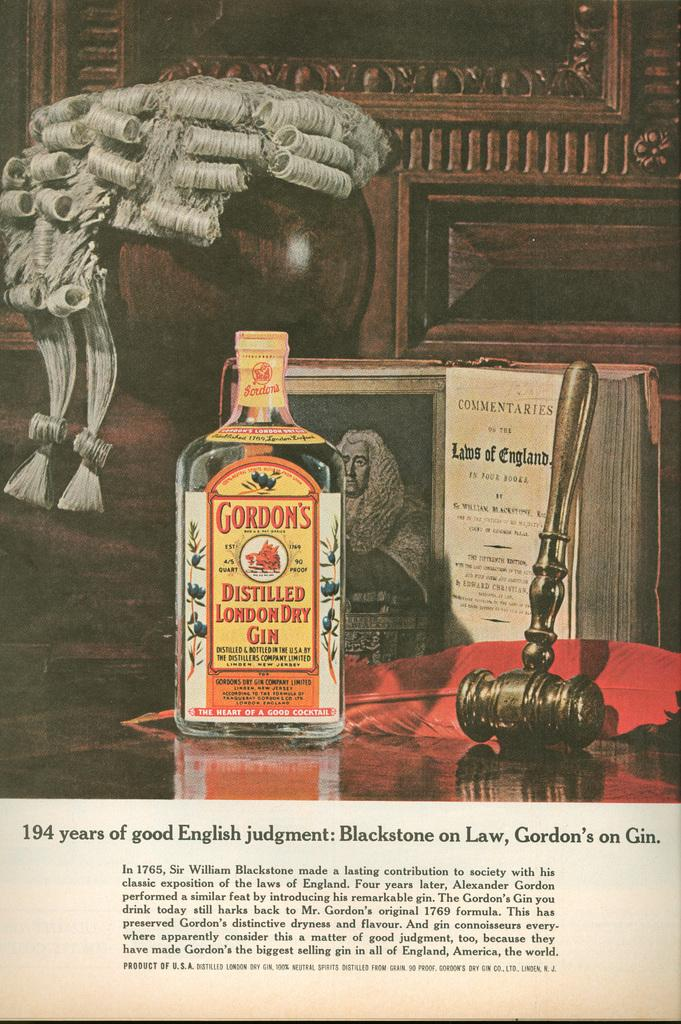Provide a one-sentence caption for the provided image. A bottle of Gordon's gin in front of a book and a small hammer. 